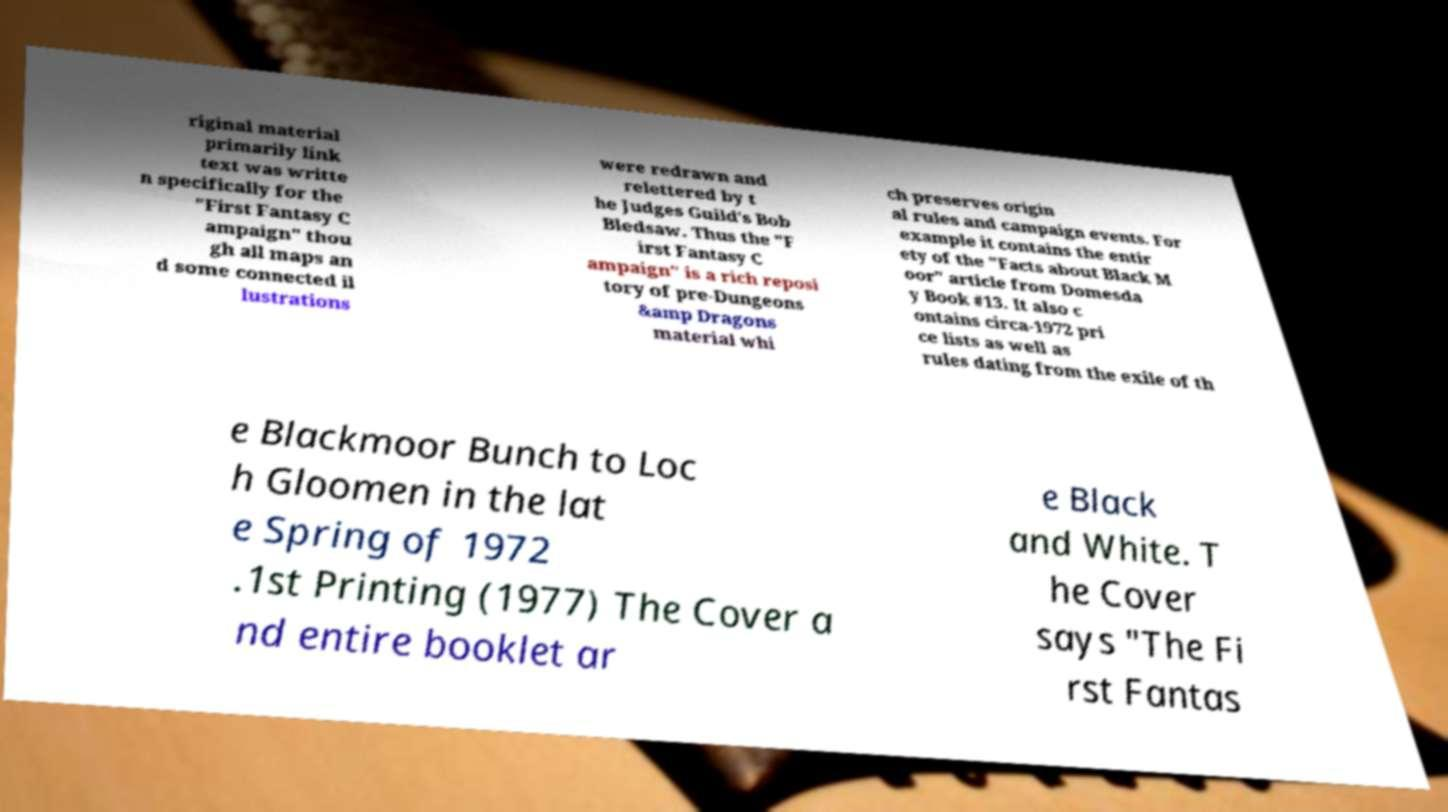Can you read and provide the text displayed in the image?This photo seems to have some interesting text. Can you extract and type it out for me? riginal material primarily link text was writte n specifically for the "First Fantasy C ampaign" thou gh all maps an d some connected il lustrations were redrawn and relettered by t he Judges Guild's Bob Bledsaw. Thus the "F irst Fantasy C ampaign" is a rich reposi tory of pre-Dungeons &amp Dragons material whi ch preserves origin al rules and campaign events. For example it contains the entir ety of the "Facts about Black M oor" article from Domesda y Book #13. It also c ontains circa-1972 pri ce lists as well as rules dating from the exile of th e Blackmoor Bunch to Loc h Gloomen in the lat e Spring of 1972 .1st Printing (1977) The Cover a nd entire booklet ar e Black and White. T he Cover says "The Fi rst Fantas 